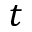<formula> <loc_0><loc_0><loc_500><loc_500>t</formula> 